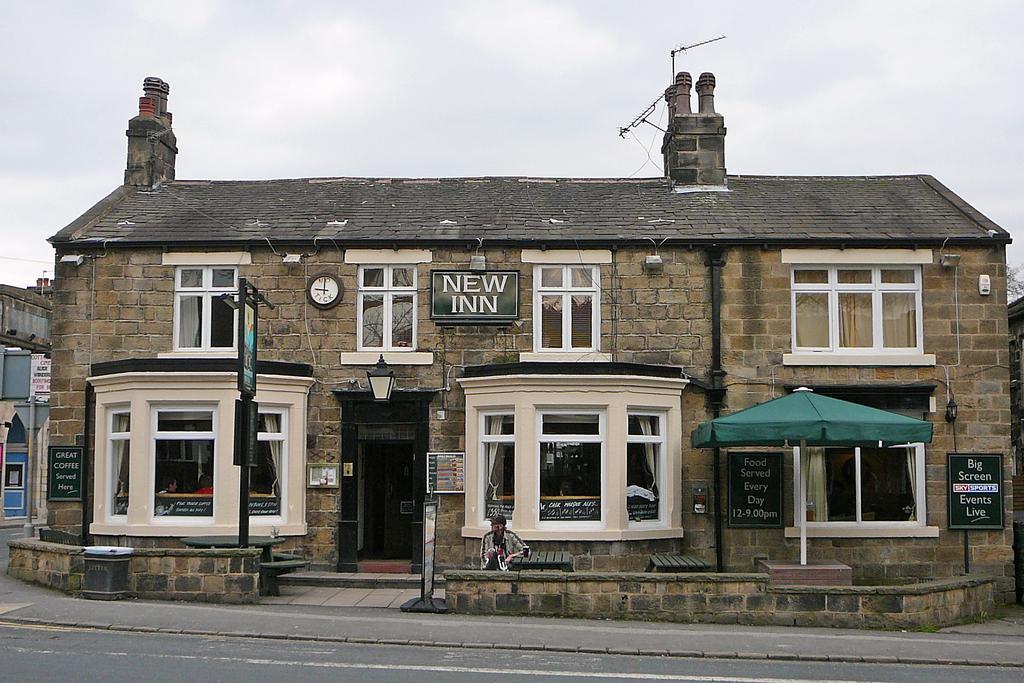Please provide a concise description of this image. In this picture we can see building, clock, windows, door, boards, lamp, tent, poles, benches, man, wall are there. At the bottom of the image there is a road. At the top of the image clouds are present in the sky. 